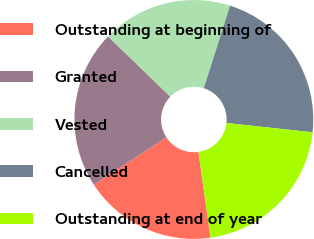Convert chart. <chart><loc_0><loc_0><loc_500><loc_500><pie_chart><fcel>Outstanding at beginning of<fcel>Granted<fcel>Vested<fcel>Cancelled<fcel>Outstanding at end of year<nl><fcel>18.04%<fcel>21.43%<fcel>17.66%<fcel>21.81%<fcel>21.05%<nl></chart> 